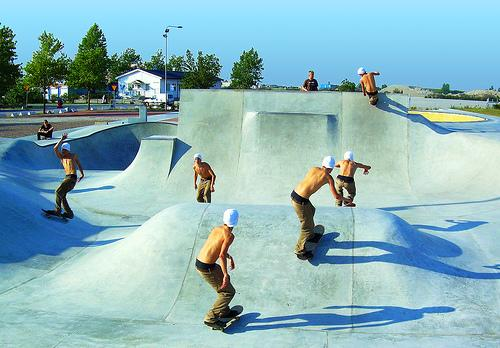Which person appears to be more of a either a spectator or observer in this scene? Describe any identifying features. A person sitting on the side of the skate track appears to be a spectator. They are wearing a black shirt and watching the skateboarders. What actions are the skateboarders performing, and how many are dressed the same way? The skateboarders are performing various tricks on a skateboard course, and six of them are dressed identically with tan pants and white hats. Are there any visible structures or objects that could be part of the surrounding environment? Provide a brief description of one. A street light is visible in the image, located at the top left corner with a gray pole and round lamps. Can you describe a noticeable element related to the lighting conditions in the image? The shadow of a skater is cast on the skate track, indicating a source of strong light in the scene. What activity are a group of men engaged in? Describe their appearance and location. A group of shirtless men, wearing white hats and tan pants, are skateboarding in a grey concrete skateboard park. What is the overall sentiment portrayed in the image? Explain your answer. The overall sentiment in the image is energetic and thrilling, as multiple skateboarders are engaged in exciting activities at a skatepark. Do the skateboarders have any common apparel or accessory? Provide a brief description. The skateboarders share common apparel of tan pants and white hats, giving them a uniform appearance. What could be a distinct feature about the skateboarding man dressed in green pants? Explain with specific details. The skater wearing green pants has a unique pose, as he is bending his body and has a hand extended in front of him. What is the general condition of the skate track? Are there any visible bystanders or onlookers around it? The skate track is bumpy and made of grey concrete. There's at least one person sitting on the side watching the skateboarders. Does the image exhibit any sign of digital manipulation? Explain your answer. Yes, the image appears to be digitally enhanced, as there are six identical men on skateboards wearing the same clothes. Are the skateboarders wearing different colored pants? This instruction is misleading because it suggests that the skateboarders are wearing different colored pants, while the provided captions mention that they are all wearing tan pants. Identify the object located at X:215 Y:195 with Width:30 and Height:30. a white hat on a head List all the captions describing the skateboarders. a bunch of men skateboarding, a bunch of men skateboarding in a skateboard park, a bunch of shirtless men skateboarding in a skateboard park, a bunch of shirtless men, a bunch of shirtless men in white hats, a bunch of men all dressed the same, two men skateboarding, men are skateboarding, the same man as he skateboards a course, six identical men on skateboards, the skateboarders have no shirts on, the skateboarders all have tan pants and white hats, six boys wearing same cloths, six boys wearing white caps. What are the dominant colors of the skateboarders' clothing? White (hats) and tan (pants). Identify any prominent object on the street in the image. a light pole on the street Is there any textual content present in the image? No OCR-related content is mentioned in the given captions. Give a description of the object located at X:151 Y:13 Width:39 Height:39. a street light What is the subject of the caption that mentions a shadow? shadow of skater cast on the skate track What is the action performed by the man located at X:190 Y:198 Width:74 Height:74? The man is skateboarding. Where is the person in a black shirt watching the skateboarders located? X:291 Y:62 Width:44 Height:44 Are there any girls skateboarding in the park? The instruction is misleading because it suggests that there are girls skateboarding, while the provided captions mention only boys or men. Describe the sentiment evoked by the image of men skateboarding. Excitement, thrill, and camaraderie. What distinctive feature is mentioned about the skate track? The skate track is bumpy and made of grey concrete. Based on the captions, is there an interaction between the skateboarders and any viewers? Yes, a person sits and watches the skateboards, and a person in a black shirt watches the skateboarders. Does the skatepark consist of grey concrete? Yes, the skatepark is grey concrete. Describe the state of the boy located at X:185 Y:198 with Width:73 and Height:73. The boy is bent. Are the skateboarders wearing helmets for safety? This is misleading because none of the skateboarders are mentioned to be wearing helmets in the given image information. Is there a dog walking on the skate track? The instruction is misleading because there is no mention of a dog in any of the provided captions for the image. What color pants does the skater wear located at X:187 Y:190 Width:80 Height:80? The skater wears green pants. Is the person watching the skateboarders wearing a red shirt? The instruction is misleading because the person watching the skateboarders is actually wearing a black shirt, not a red one. Describe the surface of the skate track in the image. The skate track is bumpy. What are the skateboarders doing in the image? The skateboarders are performing tricks in a skateboard park. Identify the anomaly in the image involving the skateboarders. The anomaly is six identical men on skateboards. Is there a viewer sitting on the side of the skate track? Yes, a viewer sits on the side of the skate track. Is there a tree next to the street light? The instruction is misleading because there is no mention of a tree in any of the provided captions. It only mentions a street light. 